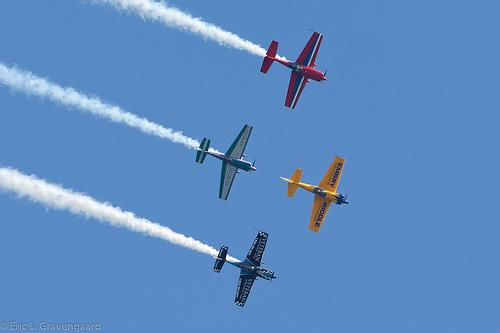What are the four major subjects in the image? Four airplanes with different colors and designs are flying together in a clear blue sky. Select one notable feature of the blue airplane. The front propeller of the blue airplane stands out in the image. List the colors used to describe each of the four airplanes in the image. Blue, yellow, red with white stripes, and green with white. Which plane exhibits blue and white lettering on it? The blue airplane showcases blue and white lettering on its exterior. For a product advertisement, describe the ideal weather conditions for flying the planes, as seen in the image. Experience the thrill of flying our airplanes under the brightest and clearest sunny blue skies, perfect for an exciting and visually stunning adventure. Explain the effect of the sky's appearance in the image. The clear, cloudless, bright blue sky provides a perfect background for the four flying airplanes and lets off white smoke trails. Describe some of the visible features of the planes, including propellers, wings, and tails. Features of the airplanes include a front propeller on the blue plane, distinct wings of different planes, the tail of a plane, and various color combinations on their designs. What does the formation of the airplanes in the sky most closely resemble? The formation of the four airplanes in the sky closely resembles a group flying tightly together in formation. Mention some details of what the yellow airplane looks like. The yellow airplane has blue letters, blue writing on the wing, and a white and blue plane in the sky. 